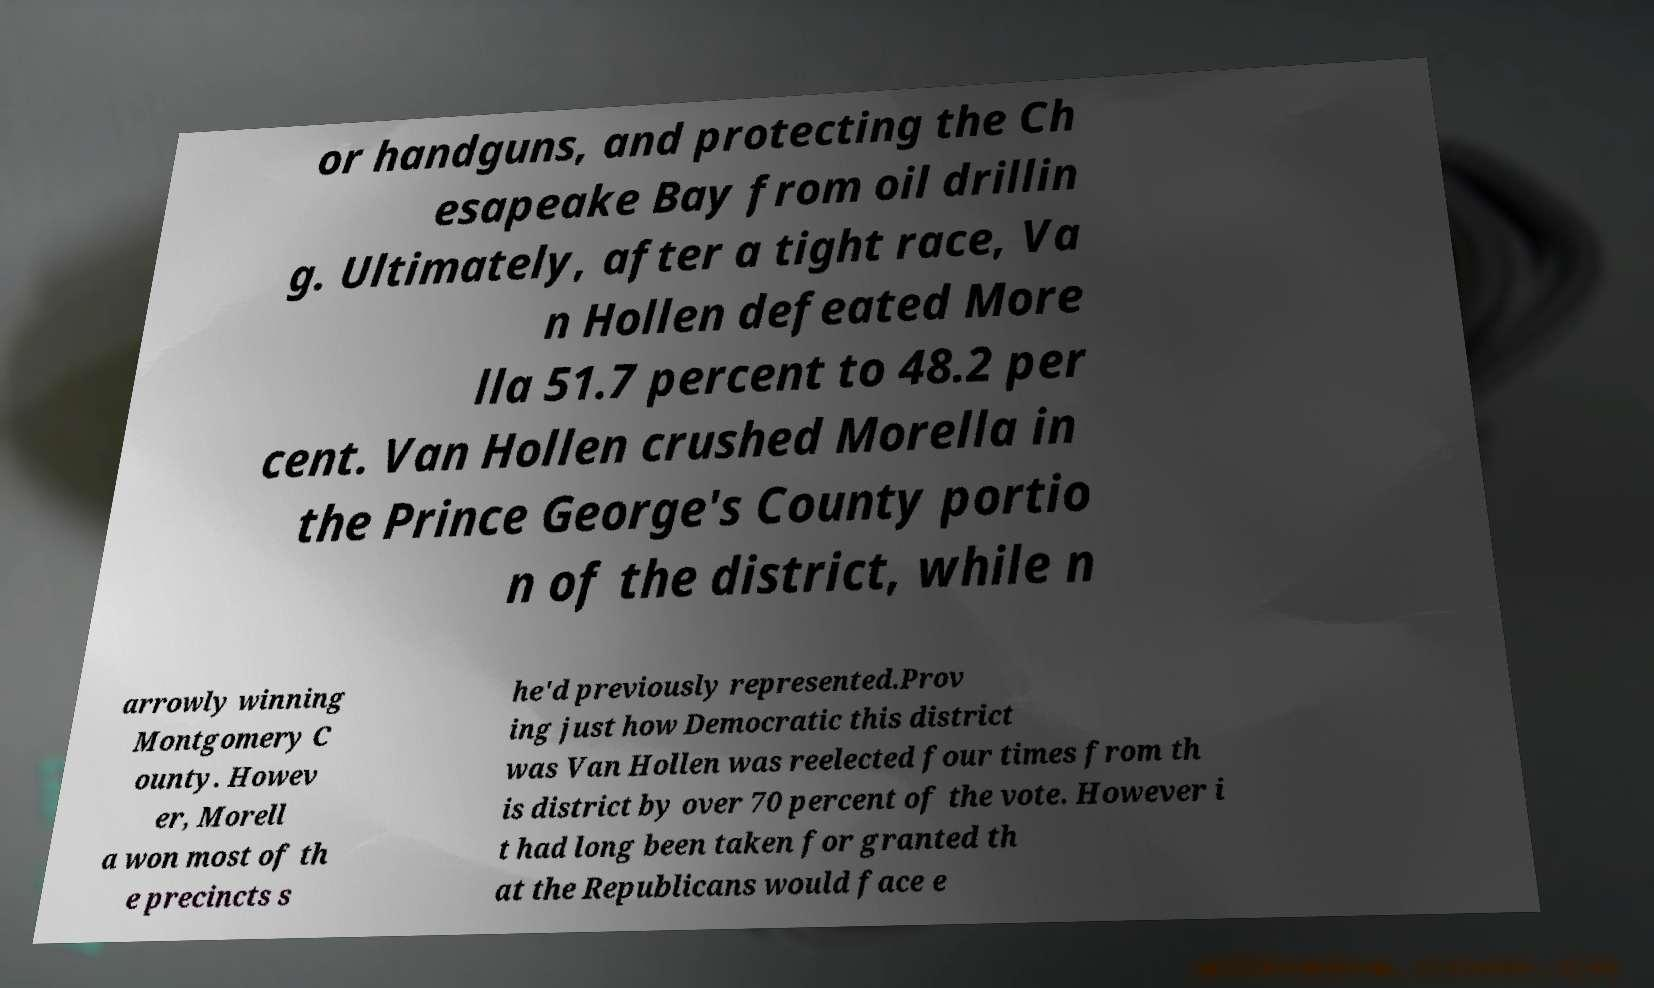Can you accurately transcribe the text from the provided image for me? or handguns, and protecting the Ch esapeake Bay from oil drillin g. Ultimately, after a tight race, Va n Hollen defeated More lla 51.7 percent to 48.2 per cent. Van Hollen crushed Morella in the Prince George's County portio n of the district, while n arrowly winning Montgomery C ounty. Howev er, Morell a won most of th e precincts s he'd previously represented.Prov ing just how Democratic this district was Van Hollen was reelected four times from th is district by over 70 percent of the vote. However i t had long been taken for granted th at the Republicans would face e 